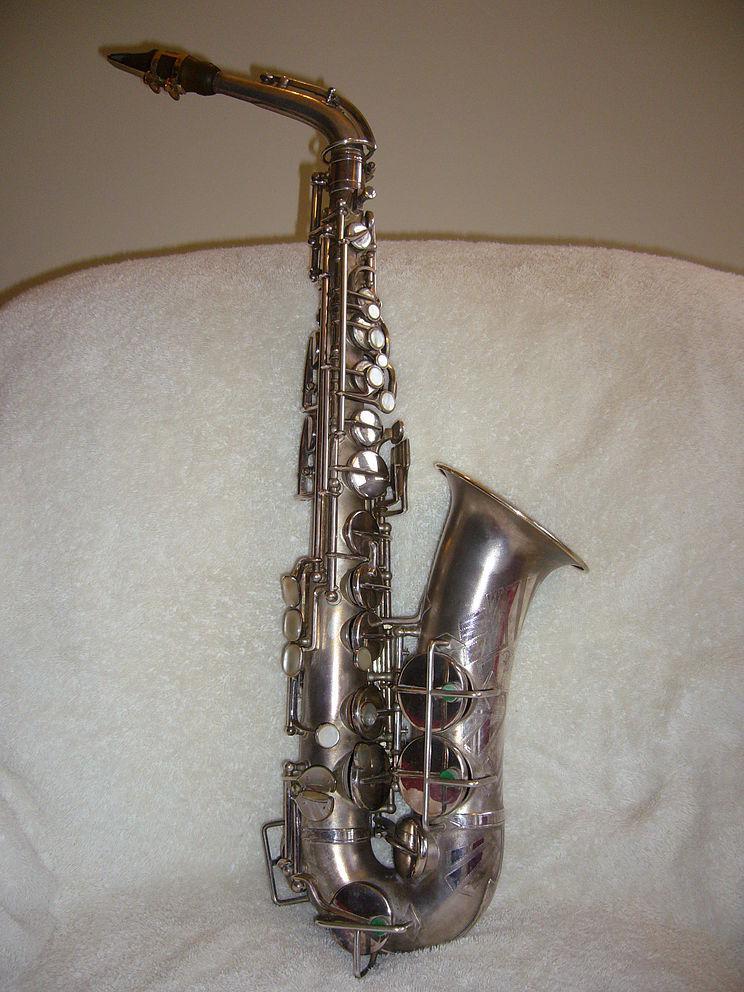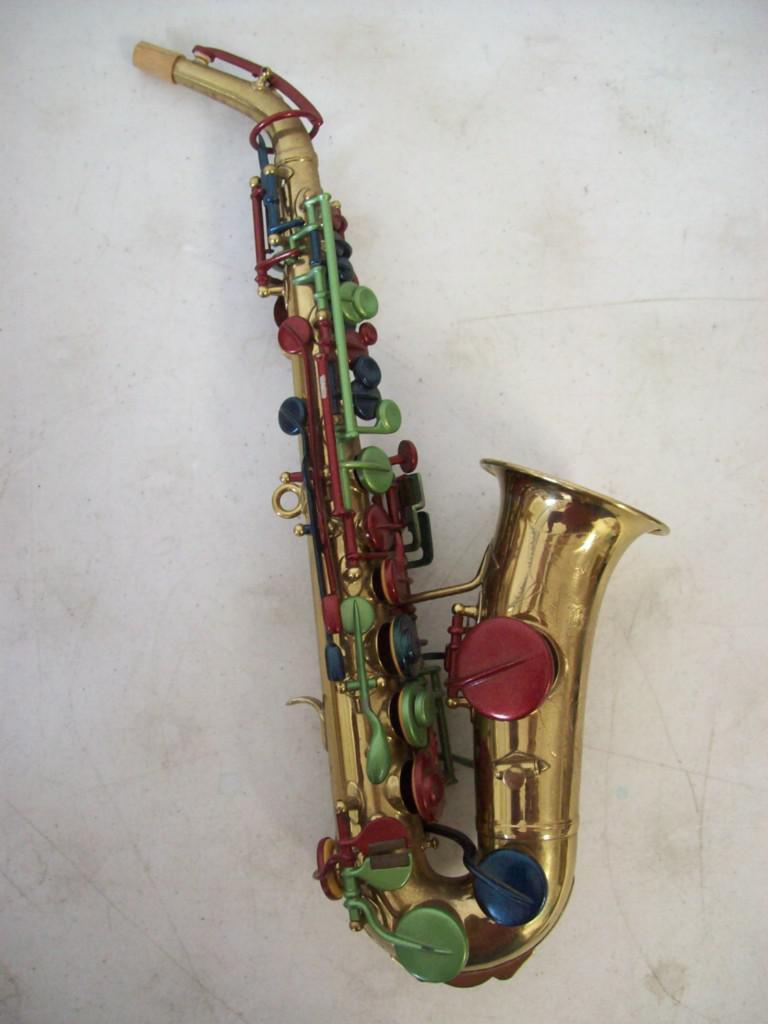The first image is the image on the left, the second image is the image on the right. Examine the images to the left and right. Is the description "An image shows an instrument with a very dark finish and brass works." accurate? Answer yes or no. No. The first image is the image on the left, the second image is the image on the right. Analyze the images presented: Is the assertion "The reed end of two saxophones angles upward." valid? Answer yes or no. Yes. 